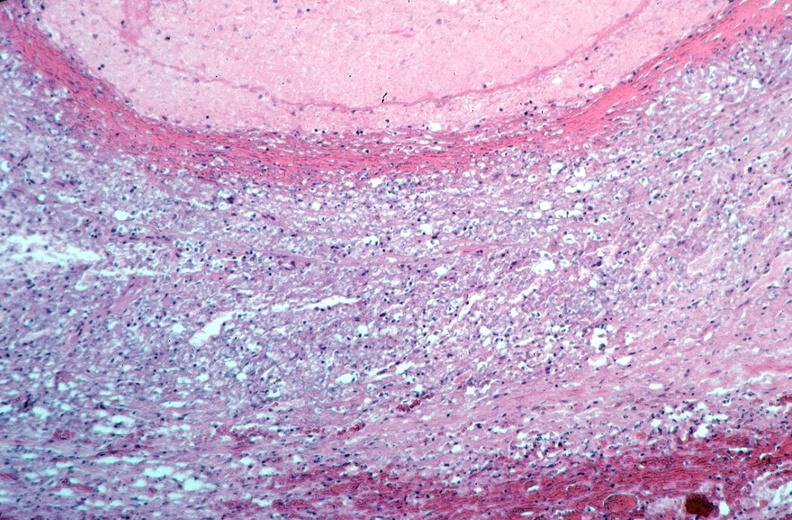does retroperitoneum show vasculitis, polyarteritis nodosa?
Answer the question using a single word or phrase. No 